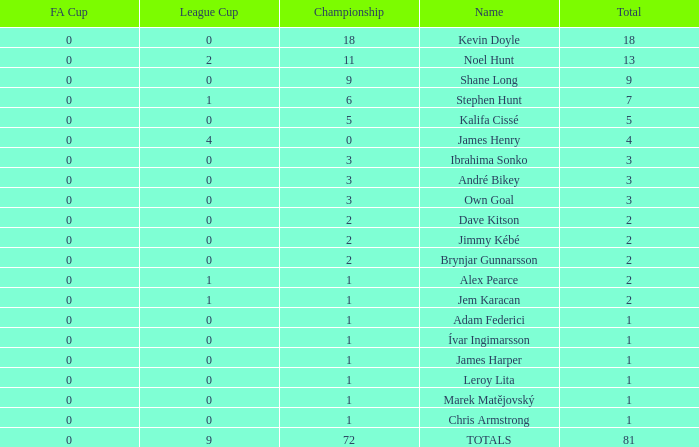What is the total championships of James Henry that has a league cup more than 1? 0.0. 